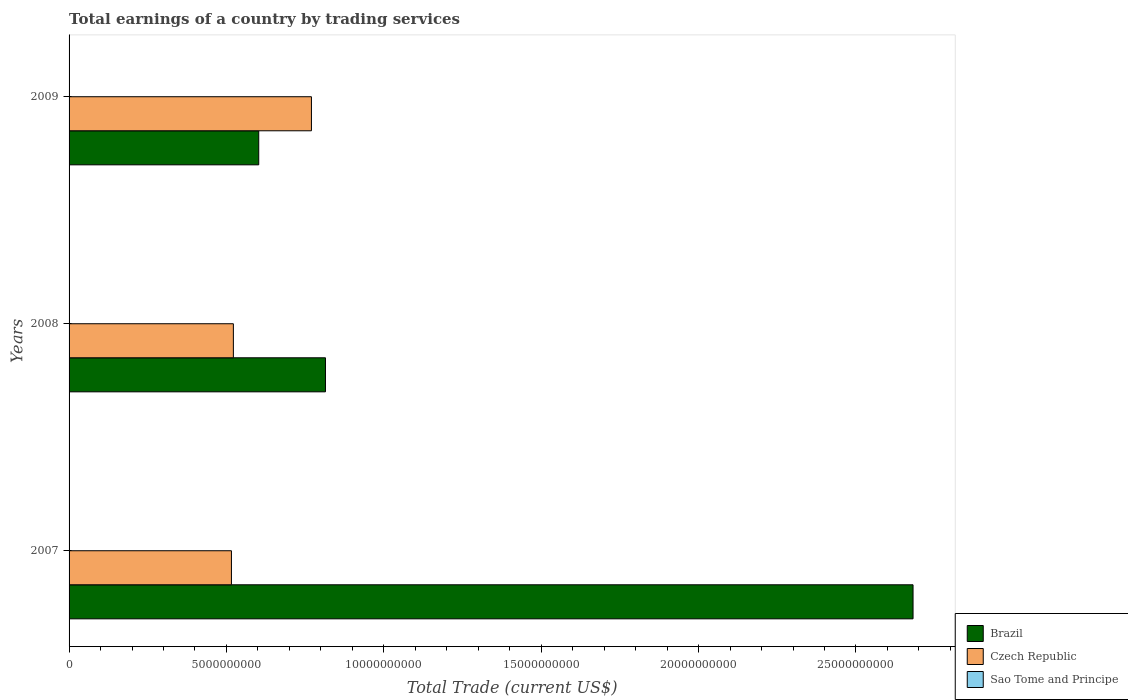How many different coloured bars are there?
Offer a very short reply. 2. How many groups of bars are there?
Your answer should be compact. 3. How many bars are there on the 2nd tick from the top?
Keep it short and to the point. 2. How many bars are there on the 3rd tick from the bottom?
Your answer should be compact. 2. What is the total earnings in Brazil in 2008?
Keep it short and to the point. 8.15e+09. Across all years, what is the maximum total earnings in Czech Republic?
Provide a short and direct response. 7.70e+09. Across all years, what is the minimum total earnings in Brazil?
Give a very brief answer. 6.03e+09. In which year was the total earnings in Brazil maximum?
Provide a short and direct response. 2007. What is the total total earnings in Brazil in the graph?
Make the answer very short. 4.10e+1. What is the difference between the total earnings in Czech Republic in 2007 and that in 2008?
Keep it short and to the point. -6.16e+07. What is the difference between the total earnings in Brazil in 2009 and the total earnings in Czech Republic in 2007?
Your answer should be compact. 8.67e+08. What is the average total earnings in Czech Republic per year?
Your answer should be very brief. 6.03e+09. In the year 2007, what is the difference between the total earnings in Czech Republic and total earnings in Brazil?
Make the answer very short. -2.17e+1. In how many years, is the total earnings in Sao Tome and Principe greater than 25000000000 US$?
Your answer should be compact. 0. What is the ratio of the total earnings in Czech Republic in 2007 to that in 2008?
Provide a short and direct response. 0.99. What is the difference between the highest and the second highest total earnings in Brazil?
Your answer should be compact. 1.87e+1. What is the difference between the highest and the lowest total earnings in Brazil?
Your response must be concise. 2.08e+1. In how many years, is the total earnings in Brazil greater than the average total earnings in Brazil taken over all years?
Provide a succinct answer. 1. Is the sum of the total earnings in Czech Republic in 2007 and 2009 greater than the maximum total earnings in Sao Tome and Principe across all years?
Your answer should be very brief. Yes. How many bars are there?
Your response must be concise. 6. Are all the bars in the graph horizontal?
Ensure brevity in your answer.  Yes. What is the difference between two consecutive major ticks on the X-axis?
Offer a terse response. 5.00e+09. Are the values on the major ticks of X-axis written in scientific E-notation?
Offer a terse response. No. Does the graph contain grids?
Give a very brief answer. No. Where does the legend appear in the graph?
Provide a succinct answer. Bottom right. How many legend labels are there?
Keep it short and to the point. 3. What is the title of the graph?
Your answer should be very brief. Total earnings of a country by trading services. Does "Romania" appear as one of the legend labels in the graph?
Provide a short and direct response. No. What is the label or title of the X-axis?
Offer a very short reply. Total Trade (current US$). What is the label or title of the Y-axis?
Keep it short and to the point. Years. What is the Total Trade (current US$) in Brazil in 2007?
Your response must be concise. 2.68e+1. What is the Total Trade (current US$) of Czech Republic in 2007?
Your response must be concise. 5.16e+09. What is the Total Trade (current US$) of Sao Tome and Principe in 2007?
Provide a short and direct response. 0. What is the Total Trade (current US$) of Brazil in 2008?
Give a very brief answer. 8.15e+09. What is the Total Trade (current US$) of Czech Republic in 2008?
Ensure brevity in your answer.  5.22e+09. What is the Total Trade (current US$) in Sao Tome and Principe in 2008?
Ensure brevity in your answer.  0. What is the Total Trade (current US$) of Brazil in 2009?
Give a very brief answer. 6.03e+09. What is the Total Trade (current US$) of Czech Republic in 2009?
Give a very brief answer. 7.70e+09. Across all years, what is the maximum Total Trade (current US$) in Brazil?
Your answer should be very brief. 2.68e+1. Across all years, what is the maximum Total Trade (current US$) in Czech Republic?
Your answer should be very brief. 7.70e+09. Across all years, what is the minimum Total Trade (current US$) in Brazil?
Provide a succinct answer. 6.03e+09. Across all years, what is the minimum Total Trade (current US$) of Czech Republic?
Offer a terse response. 5.16e+09. What is the total Total Trade (current US$) in Brazil in the graph?
Make the answer very short. 4.10e+1. What is the total Total Trade (current US$) in Czech Republic in the graph?
Your answer should be compact. 1.81e+1. What is the difference between the Total Trade (current US$) in Brazil in 2007 and that in 2008?
Offer a terse response. 1.87e+1. What is the difference between the Total Trade (current US$) in Czech Republic in 2007 and that in 2008?
Give a very brief answer. -6.16e+07. What is the difference between the Total Trade (current US$) in Brazil in 2007 and that in 2009?
Your answer should be compact. 2.08e+1. What is the difference between the Total Trade (current US$) in Czech Republic in 2007 and that in 2009?
Your answer should be compact. -2.54e+09. What is the difference between the Total Trade (current US$) in Brazil in 2008 and that in 2009?
Your answer should be compact. 2.12e+09. What is the difference between the Total Trade (current US$) of Czech Republic in 2008 and that in 2009?
Give a very brief answer. -2.48e+09. What is the difference between the Total Trade (current US$) of Brazil in 2007 and the Total Trade (current US$) of Czech Republic in 2008?
Offer a terse response. 2.16e+1. What is the difference between the Total Trade (current US$) of Brazil in 2007 and the Total Trade (current US$) of Czech Republic in 2009?
Ensure brevity in your answer.  1.91e+1. What is the difference between the Total Trade (current US$) of Brazil in 2008 and the Total Trade (current US$) of Czech Republic in 2009?
Keep it short and to the point. 4.46e+08. What is the average Total Trade (current US$) in Brazil per year?
Give a very brief answer. 1.37e+1. What is the average Total Trade (current US$) of Czech Republic per year?
Offer a very short reply. 6.03e+09. In the year 2007, what is the difference between the Total Trade (current US$) in Brazil and Total Trade (current US$) in Czech Republic?
Offer a terse response. 2.17e+1. In the year 2008, what is the difference between the Total Trade (current US$) in Brazil and Total Trade (current US$) in Czech Republic?
Give a very brief answer. 2.93e+09. In the year 2009, what is the difference between the Total Trade (current US$) of Brazil and Total Trade (current US$) of Czech Republic?
Give a very brief answer. -1.67e+09. What is the ratio of the Total Trade (current US$) of Brazil in 2007 to that in 2008?
Provide a succinct answer. 3.29. What is the ratio of the Total Trade (current US$) of Czech Republic in 2007 to that in 2008?
Keep it short and to the point. 0.99. What is the ratio of the Total Trade (current US$) in Brazil in 2007 to that in 2009?
Offer a terse response. 4.45. What is the ratio of the Total Trade (current US$) of Czech Republic in 2007 to that in 2009?
Your answer should be very brief. 0.67. What is the ratio of the Total Trade (current US$) of Brazil in 2008 to that in 2009?
Your answer should be compact. 1.35. What is the ratio of the Total Trade (current US$) of Czech Republic in 2008 to that in 2009?
Your response must be concise. 0.68. What is the difference between the highest and the second highest Total Trade (current US$) of Brazil?
Offer a terse response. 1.87e+1. What is the difference between the highest and the second highest Total Trade (current US$) of Czech Republic?
Ensure brevity in your answer.  2.48e+09. What is the difference between the highest and the lowest Total Trade (current US$) of Brazil?
Your answer should be compact. 2.08e+1. What is the difference between the highest and the lowest Total Trade (current US$) in Czech Republic?
Your answer should be compact. 2.54e+09. 